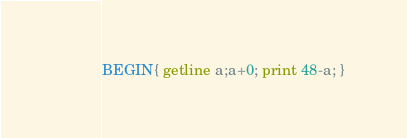Convert code to text. <code><loc_0><loc_0><loc_500><loc_500><_Awk_>BEGIN{ getline a;a+0; print 48-a; } </code> 